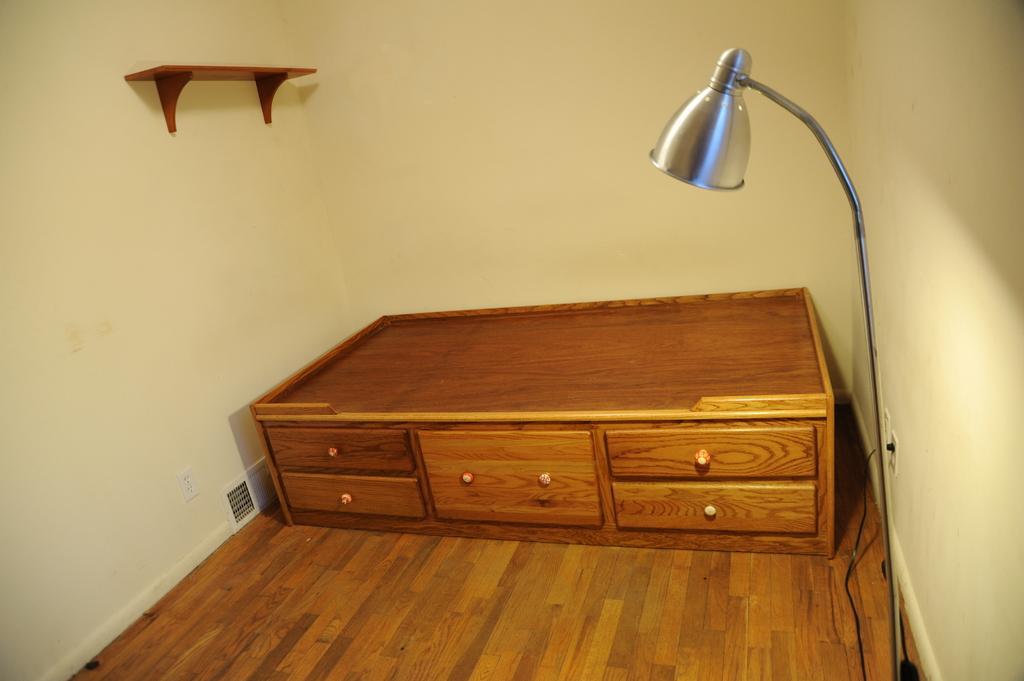In one or two sentences, can you explain what this image depicts? In this picture there is a desk, lamp, shelf. 